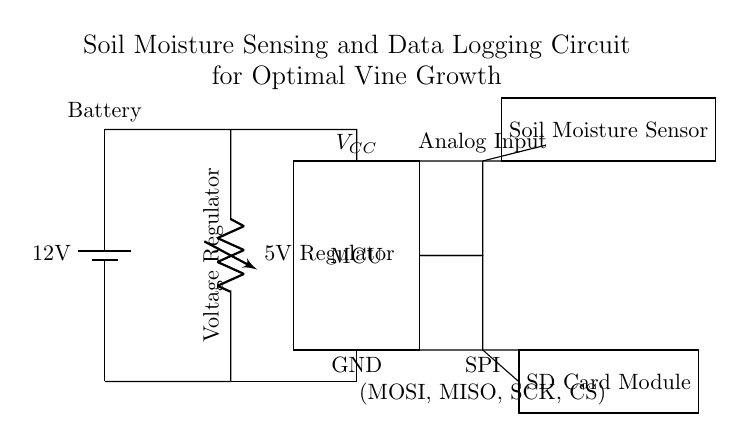What is the working voltage of the microcontroller? The microcontroller operates at 5 volts, which is supplied by the voltage regulator. This is indicated in the circuit where it shows a 5V regulator connected to the MCU.
Answer: 5 volts What component is used for soil moisture detection? The soil moisture sensor is specifically indicated in the diagram, labeled clearly as "Soil Moisture Sensor". This sensor is used to detect the moisture content in the soil.
Answer: Soil Moisture Sensor How is the soil moisture sensor connected to the microcontroller? The soil moisture sensor connects to the microcontroller via an analog input line, indicated by a short connection from the sensor to the MCU in the circuit. The connection can be seen flowing from the sensor towards the MCU at a particular point.
Answer: Analog Input What is the primary function of the SD card module? The SD card module serves as a data logger, allowing the system to store recorded soil moisture data. In the circuit, it is connected to the microcontroller, which indicates that it will be used to log data for later retrieval.
Answer: Data logging What type of connection is used between the microcontroller and SD card module? The connection is an SPI interface, which is indicated in the diagram by the label showing "SPI (MOSI, MISO, SCK, CS)". This is a common protocol for communication between the microcontroller and peripherals like an SD card.
Answer: SPI What is the voltage supplied to the soil moisture sensor? The soil moisture sensor receives a 5 volt supply, as it is connected to the same voltage regulator output that supplies the microcontroller. This is a standard setup for ensuring the sensor operates correctly.
Answer: 5 volts How many power sources are indicated in the circuit? There are two power sources depicted: a 12V battery for initial power and a 5V voltage regulator that supplies power to the microcontroller and soil moisture sensor. The diagram differentiates between the power supply sections.
Answer: Two 